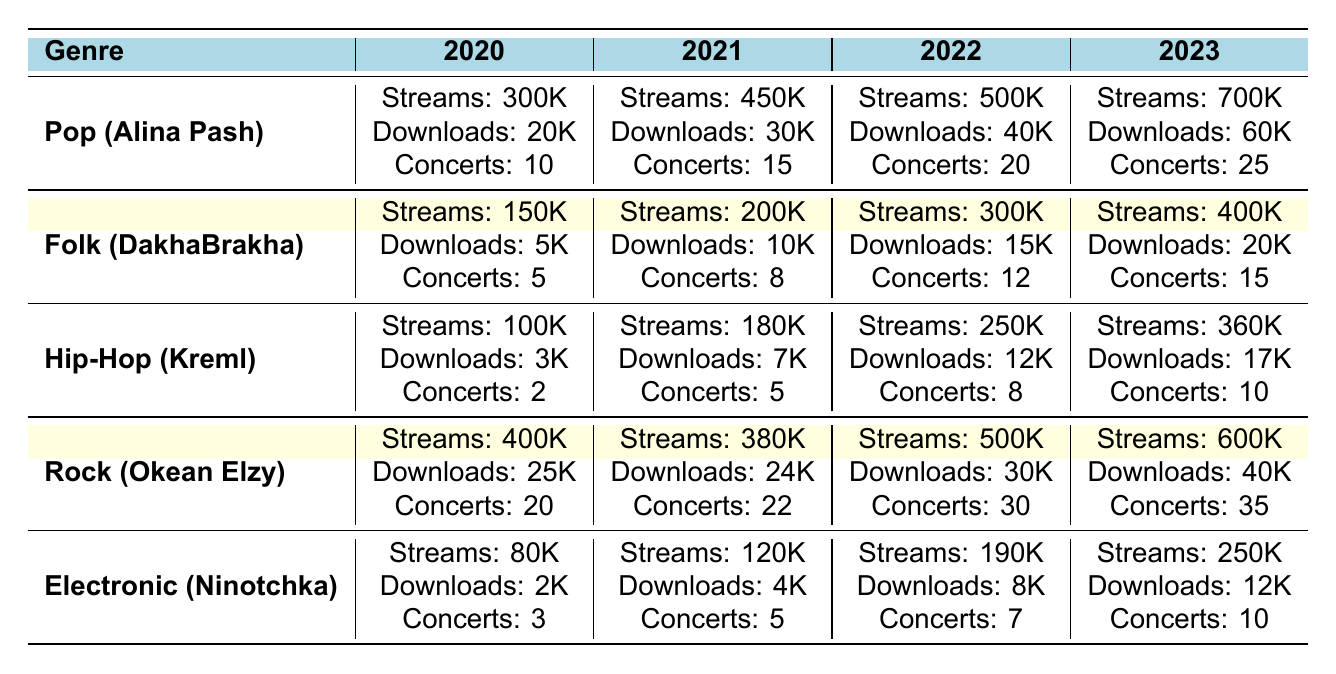What was the total number of streams for Alina Pash from 2020 to 2023? The total streams can be found by adding the streams for each year: 300,000 (2020) + 450,000 (2021) + 500,000 (2022) + 700,000 (2023) = 1,950,000.
Answer: 1,950,000 In which year did DakhaBrakha have the highest number of concerts? The concerts for DakhaBrakha were: 5 (2020), 8 (2021), 12 (2022), and 15 (2023). The highest is 15 in 2023.
Answer: 2023 How many more downloads did Okean Elzy have in 2023 compared to 2020? Okean Elzy's downloads were 25,000 in 2020 and 40,000 in 2023. The difference is 40,000 - 25,000 = 15,000.
Answer: 15,000 What was the average number of streams for the Hip-Hop genre over the years? The streams for Hip-Hop were: 100,000 (2020), 180,000 (2021), 250,000 (2022), and 360,000 (2023). The average is (100,000 + 180,000 + 250,000 + 360,000) / 4 = 222,500.
Answer: 222,500 Which genre has the least number of concerts in 2022? The concerts for each genre in 2022 are: Pop (20), Folk (12), Hip-Hop (8), Rock (30), Electronic (7). Electronic has the least with 7 concerts.
Answer: Electronic What is the total number of concerts held for Rock genre from 2020 to 2023? The total concerts for Rock are: 20 (2020) + 22 (2021) + 30 (2022) + 35 (2023) = 107.
Answer: 107 Did the number of downloads for Ninotchka increase every year? The downloads for Ninotchka were: 2,000 (2020), 4,000 (2021), 8,000 (2022), and 12,000 (2023). Since each subsequent year's downloads are higher, the answer is yes.
Answer: Yes Which genre saw the highest growth in streams from 2020 to 2023? The growth in streams from 2020 to 2023 is: Pop (700K - 300K = 400K), Folk (400K - 150K = 250K), Hip-Hop (360K - 100K = 260K), Rock (600K - 400K = 200K), Electronic (250K - 80K = 170K). Pop has the highest growth of 400K.
Answer: Pop What percentage of total streams in 2023 were from Alina Pash? In 2023, Alina Pash had 700,000 streams and total streams across all genres were 700K + 400K + 360K + 600K + 250K = 2,410,000. The percentage is (700,000 / 2,410,000) * 100 ≈ 29.0%.
Answer: 29.0% How much did the number of concerts for DakhaBrakha increase from 2020 to 2023? The concerts for DakhaBrakha were 5 in 2020 and 15 in 2023. The increase is 15 - 5 = 10.
Answer: 10 